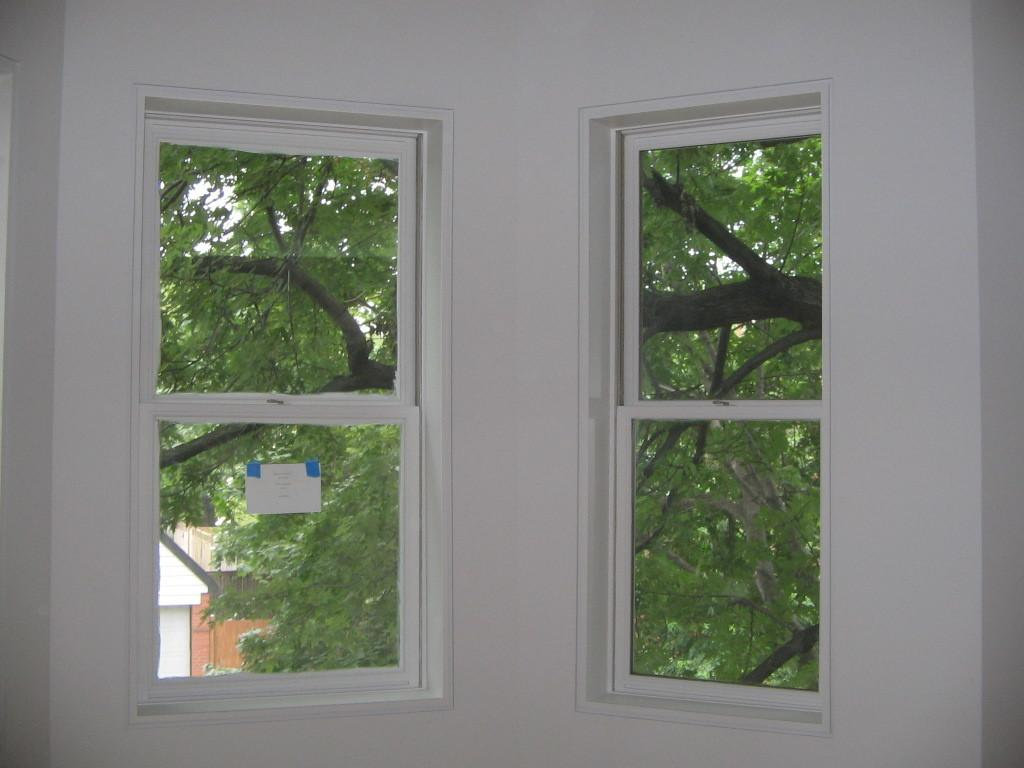What is the main object in the image? There is a window glass in the image. What can be seen through the window glass? A tree is visible in the image. What else is visible in the image besides the tree? The sky is visible in the image. Can you see a monkey biting the tree in the image? No, there is no monkey or any indication of biting in the image. 